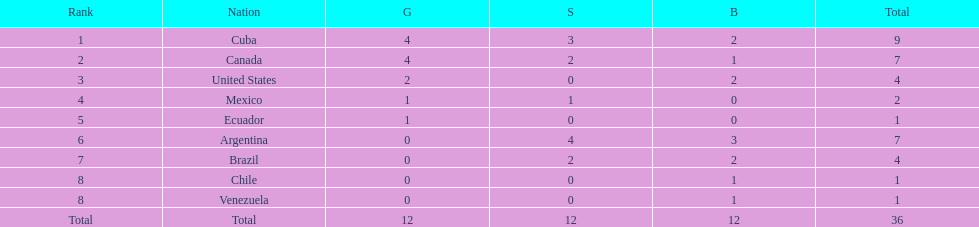Which nations won gold medals? Cuba, Canada, United States, Mexico, Ecuador. How many medals did each nation win? Cuba, 9, Canada, 7, United States, 4, Mexico, 2, Ecuador, 1. Which nation only won a gold medal? Ecuador. 